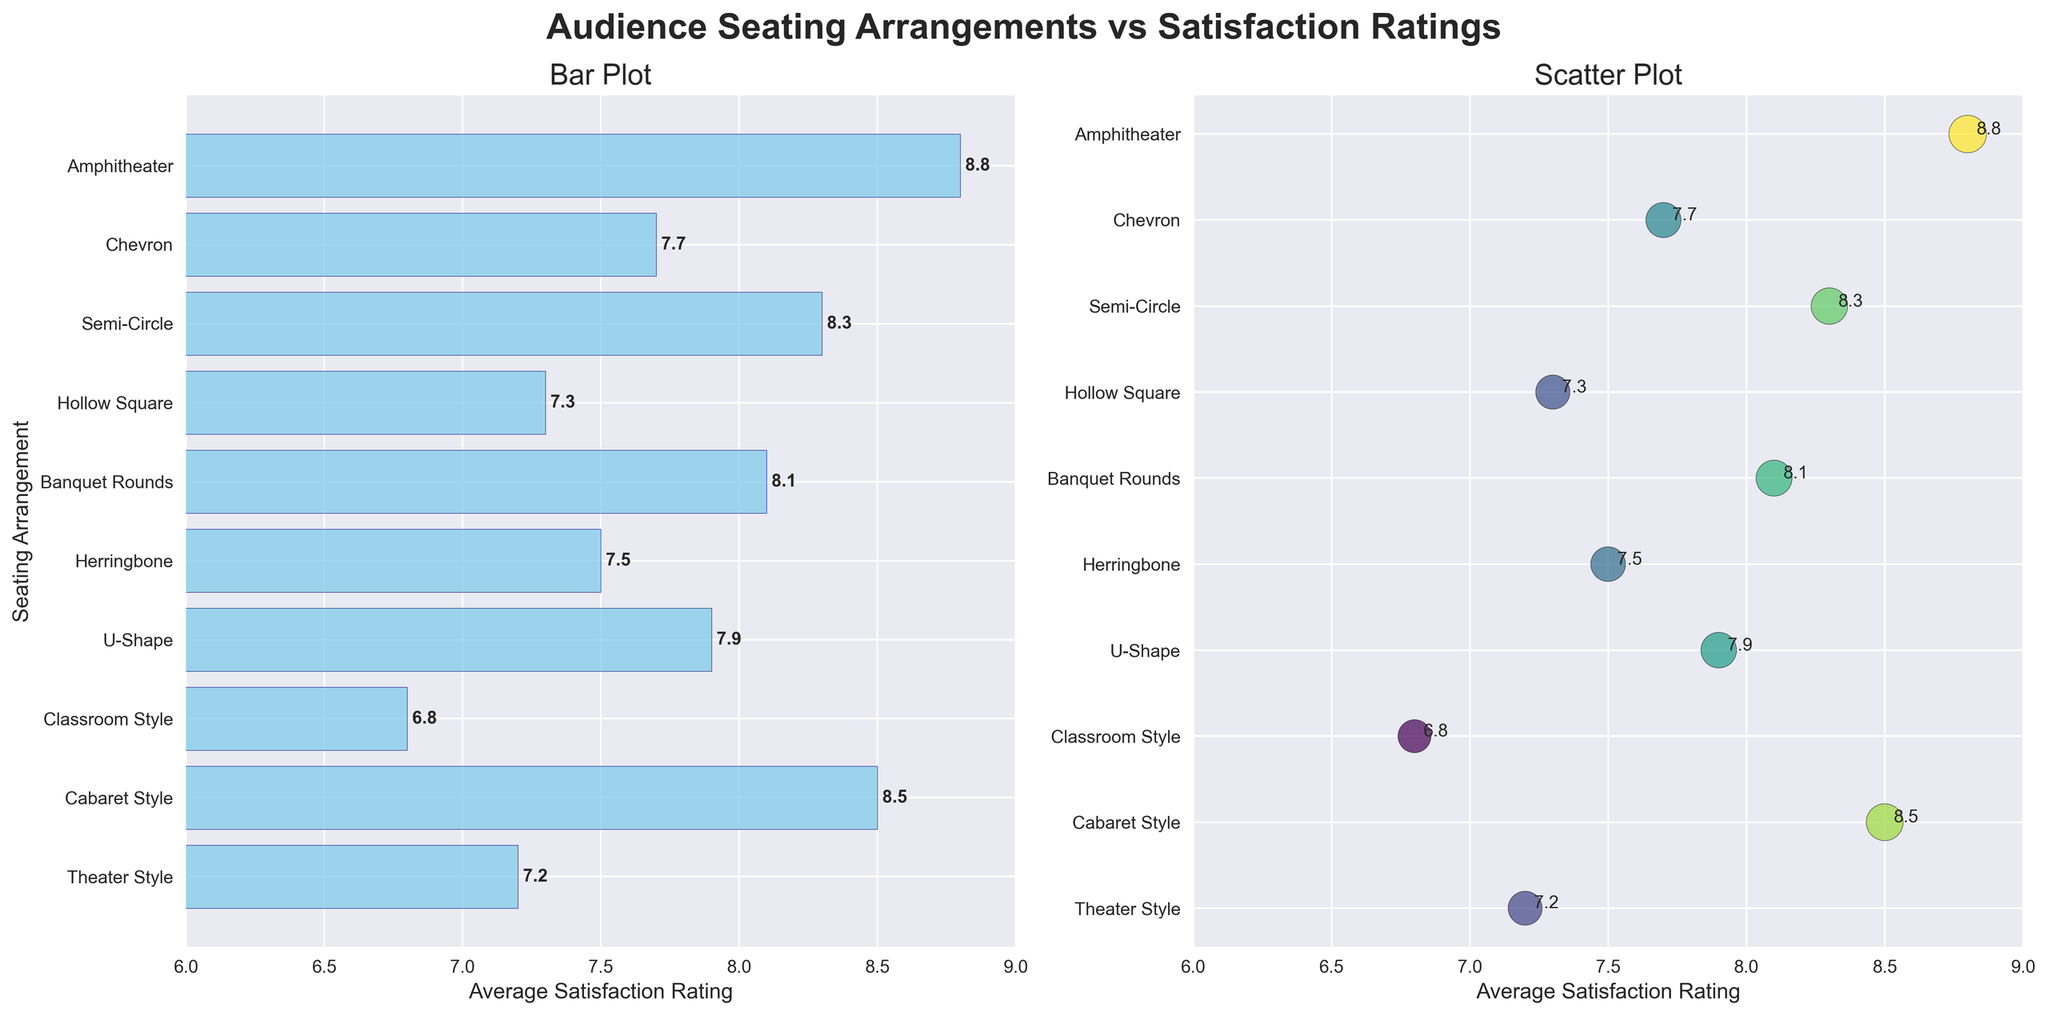Which seating arrangement has the highest average satisfaction rating? The amphitheater seating arrangement has the highest average satisfaction rating, as indicated on both the bar plot and the scatter plot, where it reaches the furthest right and has the maximum rating value of 8.8.
Answer: Amphitheater What is the average satisfaction rating for cabaret style seating? According to both the bar plot and scatter plot, the cabaret style seating has an average satisfaction rating of 8.5.
Answer: 8.5 How many seating arrangements have an average satisfaction rating below 7? From the bar plot and scatter plot, classroom style seating is the only arrangement with an average satisfaction rating below 7, precisely at 6.8.
Answer: 1 Which seating arrangement has a higher satisfaction rating: U-Shape or Chevron? The scatter plot shows that U-Shape has a satisfaction rating of 7.9, while Chevron has a rating of 7.7. Therefore, U-Shape has a higher satisfaction rating than Chevron.
Answer: U-Shape What is the difference between the highest and lowest satisfaction ratings among all seating arrangements? The highest average satisfaction rating is 8.8 (Amphitheater), and the lowest is 6.8 (Classroom Style). The difference between these ratings is 8.8 - 6.8 = 2.0.
Answer: 2.0 What is the combined average satisfaction rating for Banquet Rounds and Semi-Circle seating arrangements? The bar plot and scatter plot show that Banquet Rounds has a satisfaction rating of 8.1, and Semi-Circle has a rating of 8.3. The combined average rating is (8.1 + 8.3) / 2 = 8.2.
Answer: 8.2 How many seating arrangements have an average satisfaction rating of 7.5 or higher? By examining both the bar plot and the scatter plot, we see that Theater Style, U-Shape, Herringbone, Banquet Rounds, Semi-Circle, Chevron, and Amphitheater have ratings of 7.5 or higher, totalling 7 arrangements.
Answer: 7 What is the median average satisfaction rating of all seating arrangements? Ordering the ratings: 6.8, 7.2, 7.3, 7.5, 7.7, 7.9, 8.1, 8.3, 8.5, 8.8; the middle values are 7.7 and 7.9. The median is (7.7 + 7.9) / 2 = 7.8.
Answer: 7.8 Which seating arrangement occupies the mid-range satisfaction rating of the group? By analyzing the range of ratings, the mid-range would be approximately the halfway between the lowest and highest values, which is around 7.8. Chevron has a rating of 7.7, which is closest to the mid-range value.
Answer: Chevron 